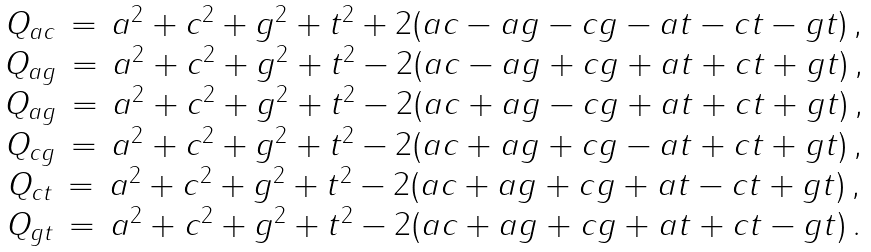Convert formula to latex. <formula><loc_0><loc_0><loc_500><loc_500>\begin{matrix} Q _ { a c } \, = \, a ^ { 2 } + c ^ { 2 } + g ^ { 2 } + t ^ { 2 } + 2 ( a c - a g - c g - a t - c t - g t ) \, , \\ Q _ { a g } \, = \, a ^ { 2 } + c ^ { 2 } + g ^ { 2 } + t ^ { 2 } - 2 ( a c - a g + c g + a t + c t + g t ) \, , \\ Q _ { a g } \, = \, a ^ { 2 } + c ^ { 2 } + g ^ { 2 } + t ^ { 2 } - 2 ( a c + a g - c g + a t + c t + g t ) \, , \\ Q _ { c g } \, = \, a ^ { 2 } + c ^ { 2 } + g ^ { 2 } + t ^ { 2 } - 2 ( a c + a g + c g - a t + c t + g t ) \, , \\ Q _ { c t } \, = \, a ^ { 2 } + c ^ { 2 } + g ^ { 2 } + t ^ { 2 } - 2 ( a c + a g + c g + a t - c t + g t ) \, , \\ Q _ { g t } \, = \, a ^ { 2 } + c ^ { 2 } + g ^ { 2 } + t ^ { 2 } - 2 ( a c + a g + c g + a t + c t - g t ) \, . \\ \end{matrix}</formula> 